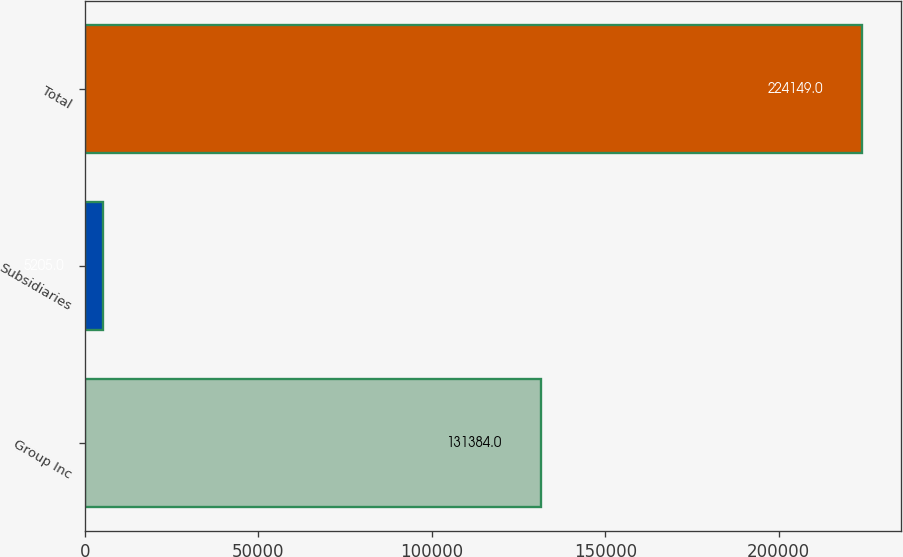Convert chart to OTSL. <chart><loc_0><loc_0><loc_500><loc_500><bar_chart><fcel>Group Inc<fcel>Subsidiaries<fcel>Total<nl><fcel>131384<fcel>5205<fcel>224149<nl></chart> 